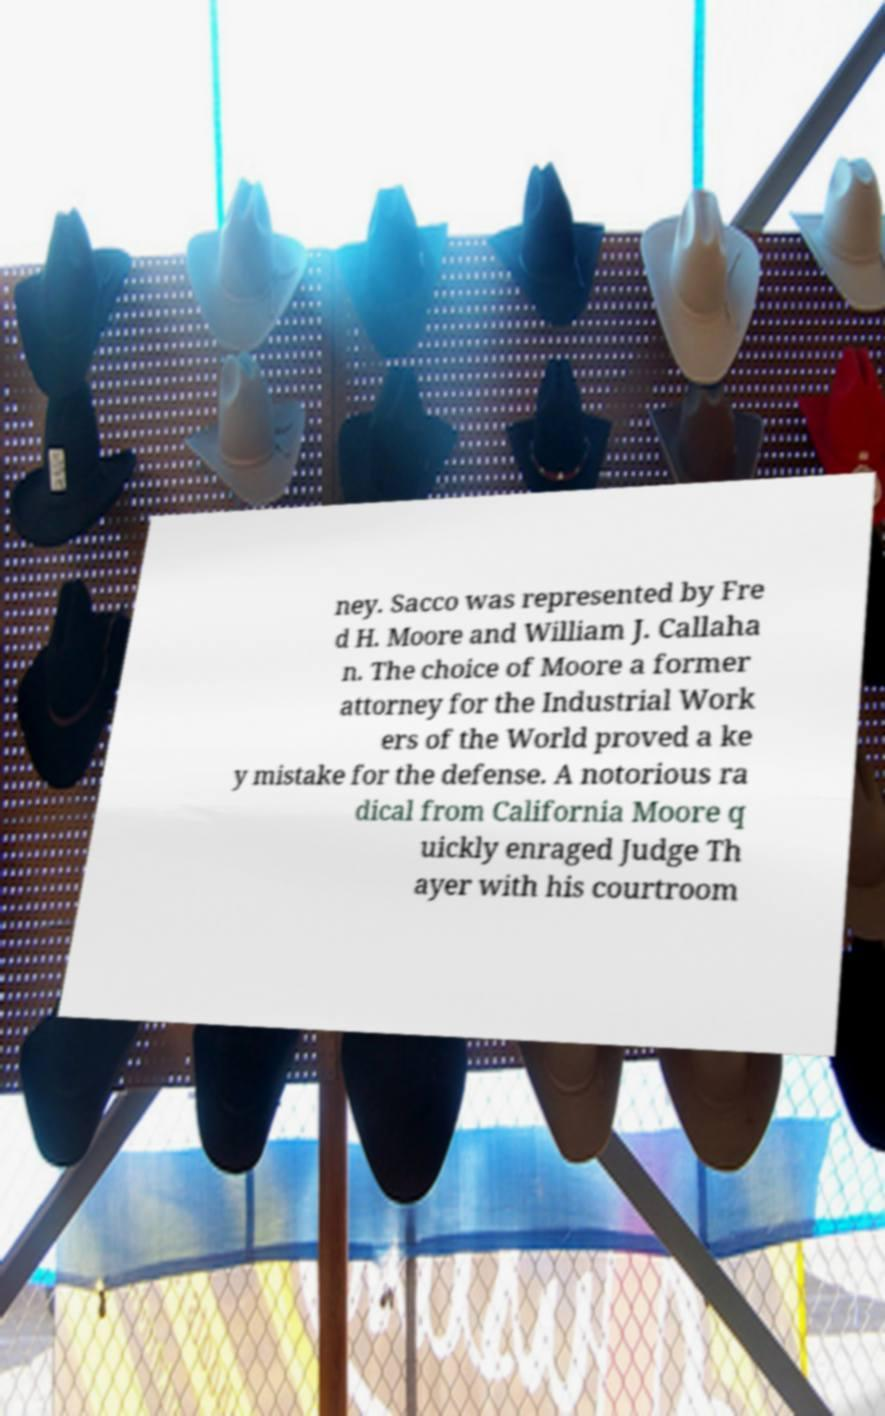Could you assist in decoding the text presented in this image and type it out clearly? ney. Sacco was represented by Fre d H. Moore and William J. Callaha n. The choice of Moore a former attorney for the Industrial Work ers of the World proved a ke y mistake for the defense. A notorious ra dical from California Moore q uickly enraged Judge Th ayer with his courtroom 